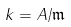<formula> <loc_0><loc_0><loc_500><loc_500>k = A / { \mathfrak { m } }</formula> 